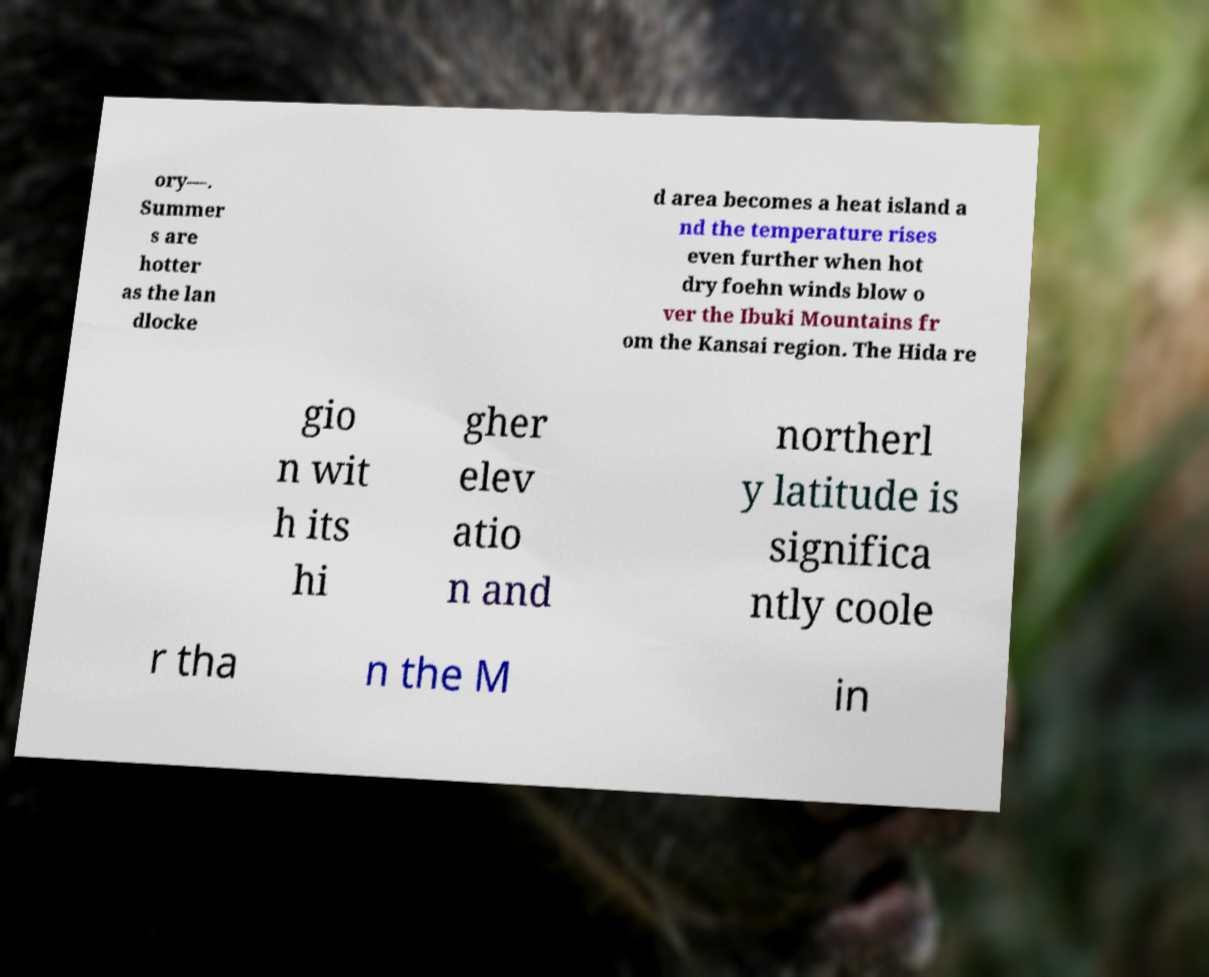Please identify and transcribe the text found in this image. ory—. Summer s are hotter as the lan dlocke d area becomes a heat island a nd the temperature rises even further when hot dry foehn winds blow o ver the Ibuki Mountains fr om the Kansai region. The Hida re gio n wit h its hi gher elev atio n and northerl y latitude is significa ntly coole r tha n the M in 